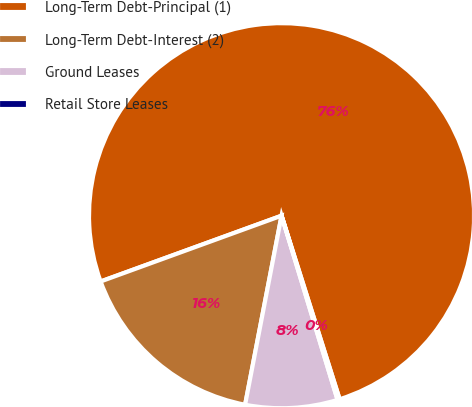Convert chart. <chart><loc_0><loc_0><loc_500><loc_500><pie_chart><fcel>Long-Term Debt-Principal (1)<fcel>Long-Term Debt-Interest (2)<fcel>Ground Leases<fcel>Retail Store Leases<nl><fcel>75.68%<fcel>16.42%<fcel>7.73%<fcel>0.18%<nl></chart> 